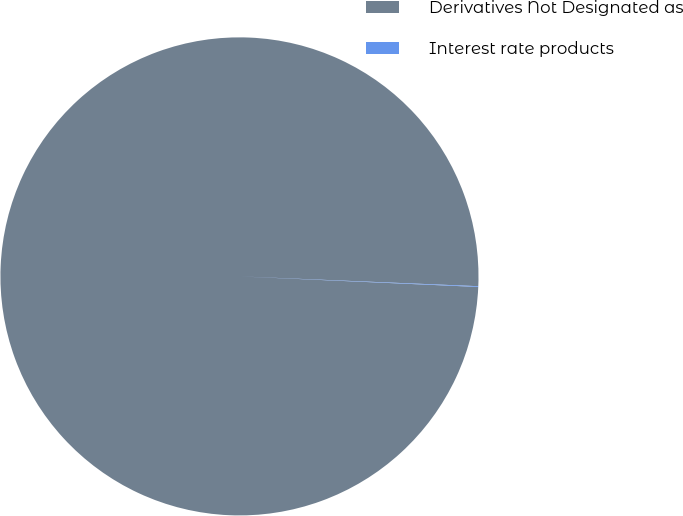<chart> <loc_0><loc_0><loc_500><loc_500><pie_chart><fcel>Derivatives Not Designated as<fcel>Interest rate products<nl><fcel>99.95%<fcel>0.05%<nl></chart> 